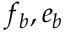<formula> <loc_0><loc_0><loc_500><loc_500>f _ { b } , e _ { b }</formula> 